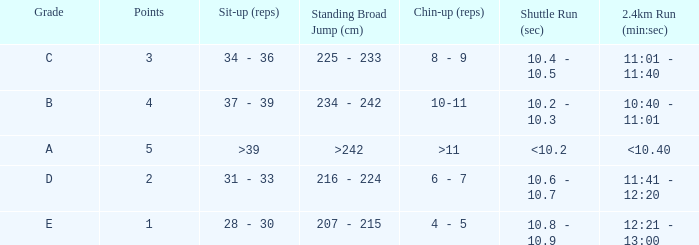Tell me the 2.4km run for points less than 2 12:21 - 13:00. 